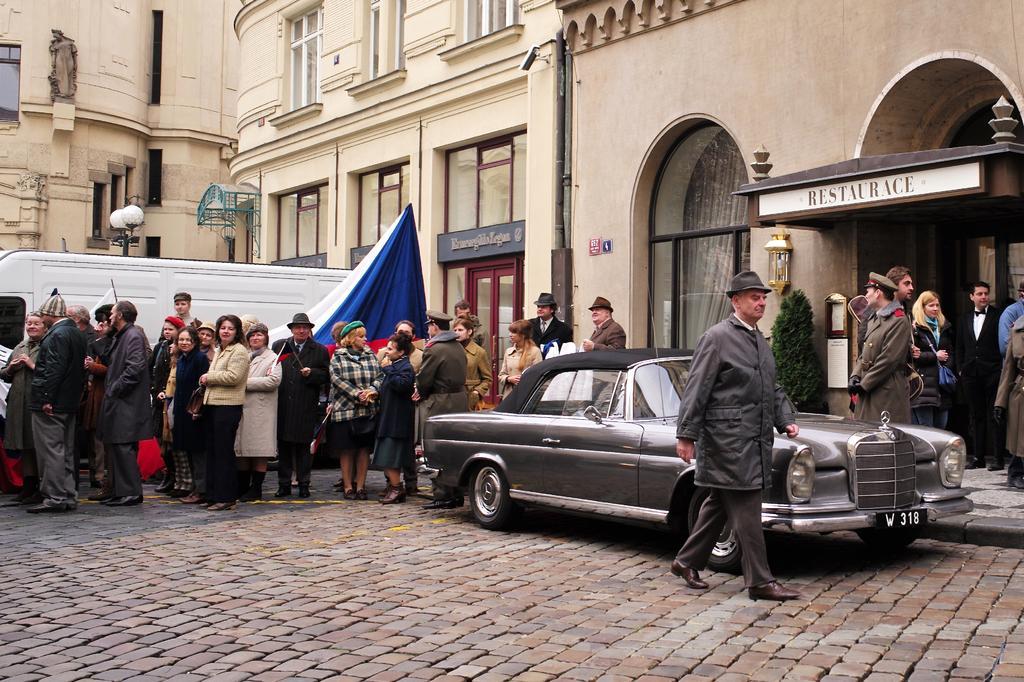Could you give a brief overview of what you see in this image? On the right side a man is walking and this is the car. On the left side few people are standing and this is the building. 